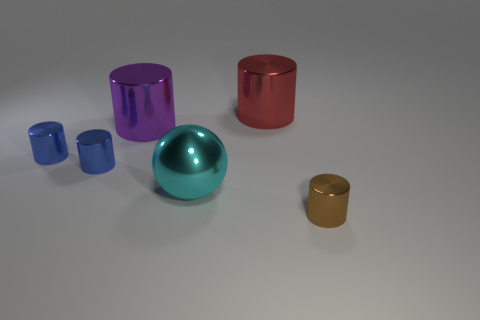Does the large metallic ball have the same color as the metal cylinder that is right of the red metal cylinder?
Offer a very short reply. No. What shape is the cyan object?
Keep it short and to the point. Sphere. There is a thing that is to the right of the large cylinder that is behind the purple thing; what size is it?
Provide a succinct answer. Small. Are there the same number of blue things behind the big red shiny object and large cylinders that are on the right side of the cyan shiny object?
Provide a short and direct response. No. What is the thing that is both right of the big cyan sphere and in front of the red metallic cylinder made of?
Your answer should be very brief. Metal. Do the cyan shiny ball and the metallic cylinder that is behind the purple metallic cylinder have the same size?
Make the answer very short. Yes. What number of other things are there of the same color as the big ball?
Keep it short and to the point. 0. Is the number of brown cylinders that are to the left of the cyan shiny ball greater than the number of gray metallic cylinders?
Keep it short and to the point. No. What color is the large shiny thing behind the big metallic cylinder that is left of the object that is behind the big purple thing?
Give a very brief answer. Red. Are the large cyan object and the big purple object made of the same material?
Provide a succinct answer. Yes. 